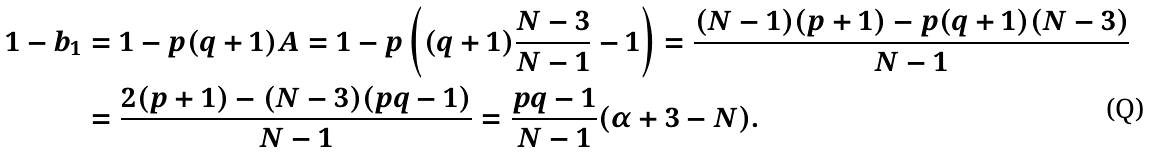<formula> <loc_0><loc_0><loc_500><loc_500>1 - b _ { 1 } & = 1 - p ( q + 1 ) A = 1 - p \left ( ( q + 1 ) \frac { N - 3 } { N - 1 } - 1 \right ) = \frac { ( N - 1 ) ( p + 1 ) - p ( q + 1 ) ( N - 3 ) } { N - 1 } \\ & = \frac { 2 ( p + 1 ) - ( N - 3 ) ( p q - 1 ) } { N - 1 } = \frac { p q - 1 } { N - 1 } ( \alpha + 3 - N ) .</formula> 